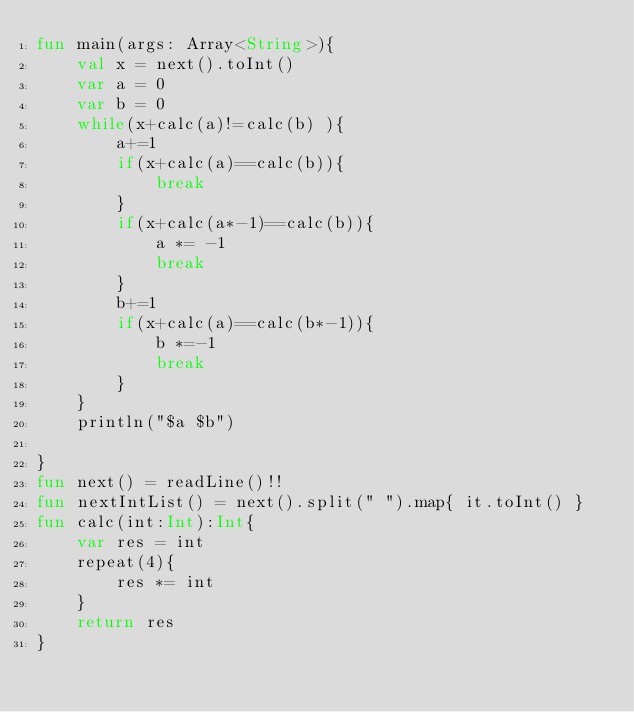<code> <loc_0><loc_0><loc_500><loc_500><_Kotlin_>fun main(args: Array<String>){
    val x = next().toInt()
    var a = 0
    var b = 0
    while(x+calc(a)!=calc(b) ){
        a+=1
        if(x+calc(a)==calc(b)){
            break
        }
        if(x+calc(a*-1)==calc(b)){
            a *= -1
            break
        }
        b+=1
        if(x+calc(a)==calc(b*-1)){
            b *=-1
            break
        }
    }
    println("$a $b")

}
fun next() = readLine()!!
fun nextIntList() = next().split(" ").map{ it.toInt() }
fun calc(int:Int):Int{
    var res = int
    repeat(4){
        res *= int
    }
    return res
}

</code> 